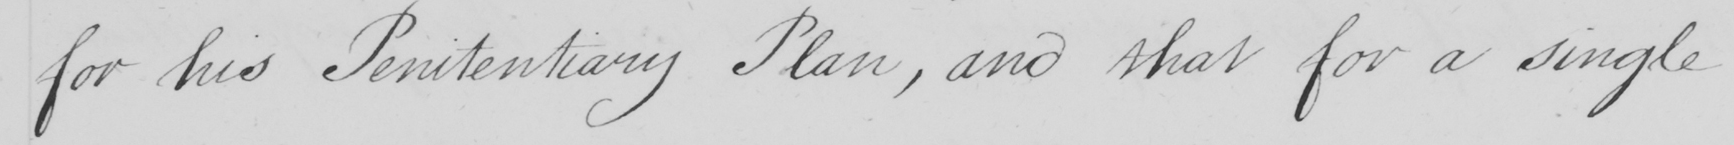Please provide the text content of this handwritten line. for his Penitentiary Plan , and that for a single 